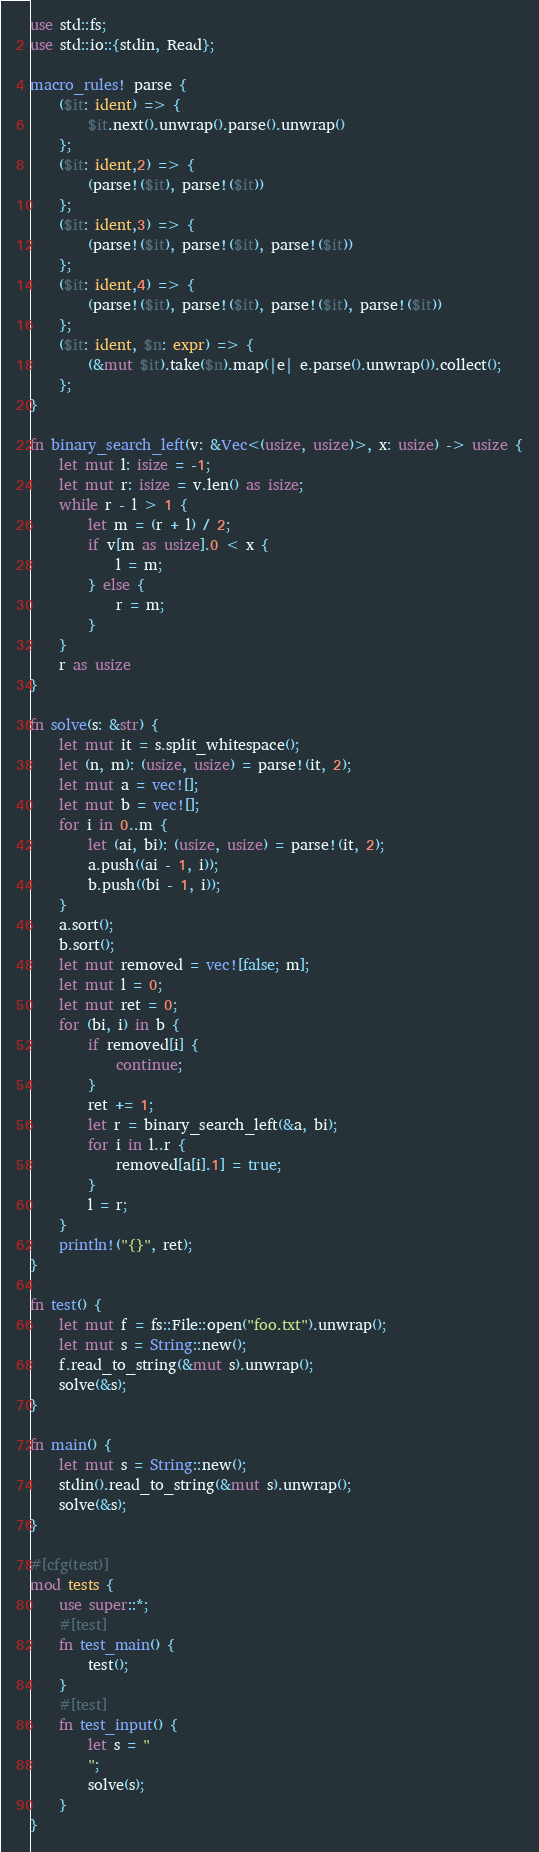Convert code to text. <code><loc_0><loc_0><loc_500><loc_500><_Rust_>use std::fs;
use std::io::{stdin, Read};

macro_rules! parse {
    ($it: ident) => {
        $it.next().unwrap().parse().unwrap()
    };
    ($it: ident,2) => {
        (parse!($it), parse!($it))
    };
    ($it: ident,3) => {
        (parse!($it), parse!($it), parse!($it))
    };
    ($it: ident,4) => {
        (parse!($it), parse!($it), parse!($it), parse!($it))
    };
    ($it: ident, $n: expr) => {
        (&mut $it).take($n).map(|e| e.parse().unwrap()).collect();
    };
}

fn binary_search_left(v: &Vec<(usize, usize)>, x: usize) -> usize {
    let mut l: isize = -1;
    let mut r: isize = v.len() as isize;
    while r - l > 1 {
        let m = (r + l) / 2;
        if v[m as usize].0 < x {
            l = m;
        } else {
            r = m;
        }
    }
    r as usize
}

fn solve(s: &str) {
    let mut it = s.split_whitespace();
    let (n, m): (usize, usize) = parse!(it, 2);
    let mut a = vec![];
    let mut b = vec![];
    for i in 0..m {
        let (ai, bi): (usize, usize) = parse!(it, 2);
        a.push((ai - 1, i));
        b.push((bi - 1, i));
    }
    a.sort();
    b.sort();
    let mut removed = vec![false; m];
    let mut l = 0;
    let mut ret = 0;
    for (bi, i) in b {
        if removed[i] {
            continue;
        }
        ret += 1;
        let r = binary_search_left(&a, bi);
        for i in l..r {
            removed[a[i].1] = true;
        }
        l = r;
    }
    println!("{}", ret);
}

fn test() {
    let mut f = fs::File::open("foo.txt").unwrap();
    let mut s = String::new();
    f.read_to_string(&mut s).unwrap();
    solve(&s);
}

fn main() {
    let mut s = String::new();
    stdin().read_to_string(&mut s).unwrap();
    solve(&s);
}

#[cfg(test)]
mod tests {
    use super::*;
    #[test]
    fn test_main() {
        test();
    }
    #[test]
    fn test_input() {
        let s = "
        ";
        solve(s);
    }
}
</code> 